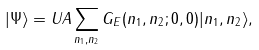<formula> <loc_0><loc_0><loc_500><loc_500>| \Psi \rangle = U A \sum _ { n _ { 1 } , n _ { 2 } } G _ { E } ( n _ { 1 } , n _ { 2 } ; 0 , 0 ) | n _ { 1 } , n _ { 2 } \rangle ,</formula> 